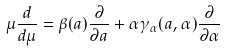<formula> <loc_0><loc_0><loc_500><loc_500>\mu \frac { d } { d \mu } = \beta ( a ) \frac { \partial } { \partial a } + \alpha \gamma _ { \alpha } ( a , \alpha ) \frac { \partial } { \partial \alpha }</formula> 